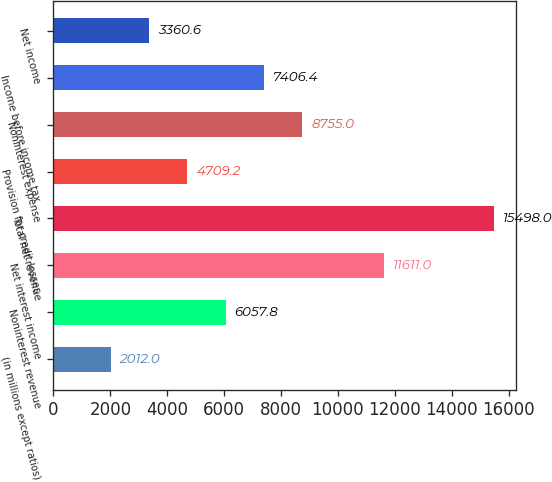<chart> <loc_0><loc_0><loc_500><loc_500><bar_chart><fcel>(in millions except ratios)<fcel>Noninterest revenue<fcel>Net interest income<fcel>Total net revenue<fcel>Provision for credit losses<fcel>Noninterest expense<fcel>Income before income tax<fcel>Net income<nl><fcel>2012<fcel>6057.8<fcel>11611<fcel>15498<fcel>4709.2<fcel>8755<fcel>7406.4<fcel>3360.6<nl></chart> 